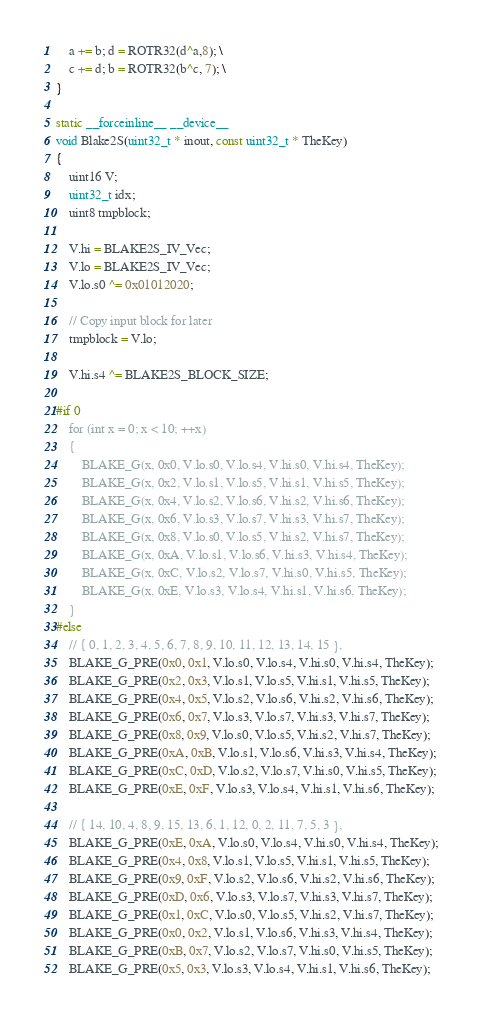<code> <loc_0><loc_0><loc_500><loc_500><_Cuda_>	a += b; d = ROTR32(d^a,8); \
	c += d; b = ROTR32(b^c, 7); \
}

static __forceinline__ __device__
void Blake2S(uint32_t * inout, const uint32_t * TheKey)
{
	uint16 V;
	uint32_t idx;
	uint8 tmpblock;

	V.hi = BLAKE2S_IV_Vec;
	V.lo = BLAKE2S_IV_Vec;
	V.lo.s0 ^= 0x01012020;

	// Copy input block for later
	tmpblock = V.lo;

	V.hi.s4 ^= BLAKE2S_BLOCK_SIZE;

#if 0
	for (int x = 0; x < 10; ++x)
	{
		BLAKE_G(x, 0x0, V.lo.s0, V.lo.s4, V.hi.s0, V.hi.s4, TheKey);
		BLAKE_G(x, 0x2, V.lo.s1, V.lo.s5, V.hi.s1, V.hi.s5, TheKey);
		BLAKE_G(x, 0x4, V.lo.s2, V.lo.s6, V.hi.s2, V.hi.s6, TheKey);
		BLAKE_G(x, 0x6, V.lo.s3, V.lo.s7, V.hi.s3, V.hi.s7, TheKey);
		BLAKE_G(x, 0x8, V.lo.s0, V.lo.s5, V.hi.s2, V.hi.s7, TheKey);
		BLAKE_G(x, 0xA, V.lo.s1, V.lo.s6, V.hi.s3, V.hi.s4, TheKey);
		BLAKE_G(x, 0xC, V.lo.s2, V.lo.s7, V.hi.s0, V.hi.s5, TheKey);
		BLAKE_G(x, 0xE, V.lo.s3, V.lo.s4, V.hi.s1, V.hi.s6, TheKey);
	}
#else
	// { 0, 1, 2, 3, 4, 5, 6, 7, 8, 9, 10, 11, 12, 13, 14, 15 },
	BLAKE_G_PRE(0x0, 0x1, V.lo.s0, V.lo.s4, V.hi.s0, V.hi.s4, TheKey);
	BLAKE_G_PRE(0x2, 0x3, V.lo.s1, V.lo.s5, V.hi.s1, V.hi.s5, TheKey);
	BLAKE_G_PRE(0x4, 0x5, V.lo.s2, V.lo.s6, V.hi.s2, V.hi.s6, TheKey);
	BLAKE_G_PRE(0x6, 0x7, V.lo.s3, V.lo.s7, V.hi.s3, V.hi.s7, TheKey);
	BLAKE_G_PRE(0x8, 0x9, V.lo.s0, V.lo.s5, V.hi.s2, V.hi.s7, TheKey);
	BLAKE_G_PRE(0xA, 0xB, V.lo.s1, V.lo.s6, V.hi.s3, V.hi.s4, TheKey);
	BLAKE_G_PRE(0xC, 0xD, V.lo.s2, V.lo.s7, V.hi.s0, V.hi.s5, TheKey);
	BLAKE_G_PRE(0xE, 0xF, V.lo.s3, V.lo.s4, V.hi.s1, V.hi.s6, TheKey);

	// { 14, 10, 4, 8, 9, 15, 13, 6, 1, 12, 0, 2, 11, 7, 5, 3 },
	BLAKE_G_PRE(0xE, 0xA, V.lo.s0, V.lo.s4, V.hi.s0, V.hi.s4, TheKey);
	BLAKE_G_PRE(0x4, 0x8, V.lo.s1, V.lo.s5, V.hi.s1, V.hi.s5, TheKey);
	BLAKE_G_PRE(0x9, 0xF, V.lo.s2, V.lo.s6, V.hi.s2, V.hi.s6, TheKey);
	BLAKE_G_PRE(0xD, 0x6, V.lo.s3, V.lo.s7, V.hi.s3, V.hi.s7, TheKey);
	BLAKE_G_PRE(0x1, 0xC, V.lo.s0, V.lo.s5, V.hi.s2, V.hi.s7, TheKey);
	BLAKE_G_PRE(0x0, 0x2, V.lo.s1, V.lo.s6, V.hi.s3, V.hi.s4, TheKey);
	BLAKE_G_PRE(0xB, 0x7, V.lo.s2, V.lo.s7, V.hi.s0, V.hi.s5, TheKey);
	BLAKE_G_PRE(0x5, 0x3, V.lo.s3, V.lo.s4, V.hi.s1, V.hi.s6, TheKey);
</code> 